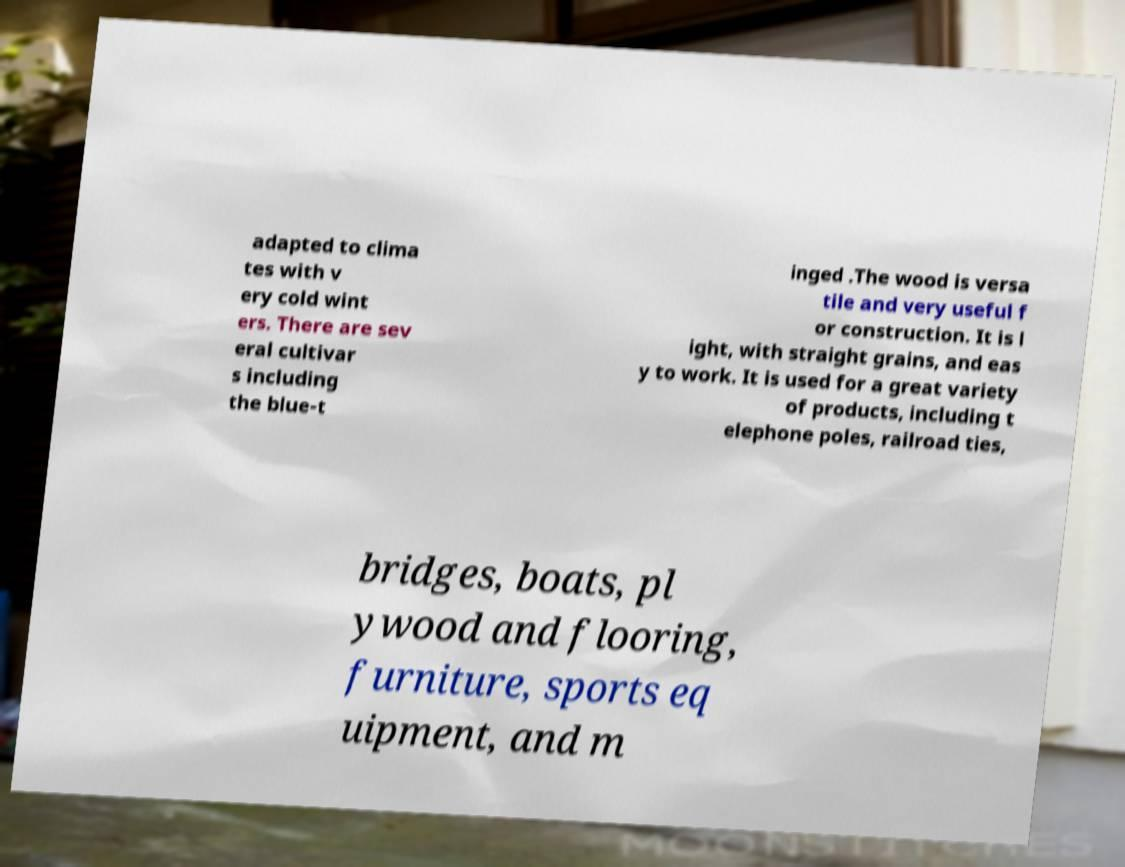Can you read and provide the text displayed in the image?This photo seems to have some interesting text. Can you extract and type it out for me? adapted to clima tes with v ery cold wint ers. There are sev eral cultivar s including the blue-t inged .The wood is versa tile and very useful f or construction. It is l ight, with straight grains, and eas y to work. It is used for a great variety of products, including t elephone poles, railroad ties, bridges, boats, pl ywood and flooring, furniture, sports eq uipment, and m 